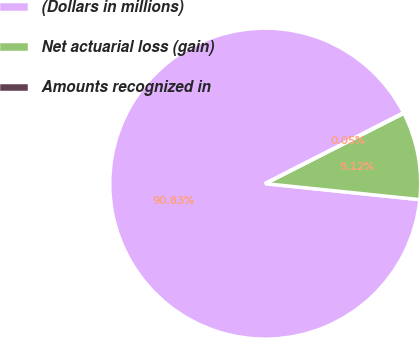Convert chart to OTSL. <chart><loc_0><loc_0><loc_500><loc_500><pie_chart><fcel>(Dollars in millions)<fcel>Net actuarial loss (gain)<fcel>Amounts recognized in<nl><fcel>90.83%<fcel>9.12%<fcel>0.05%<nl></chart> 